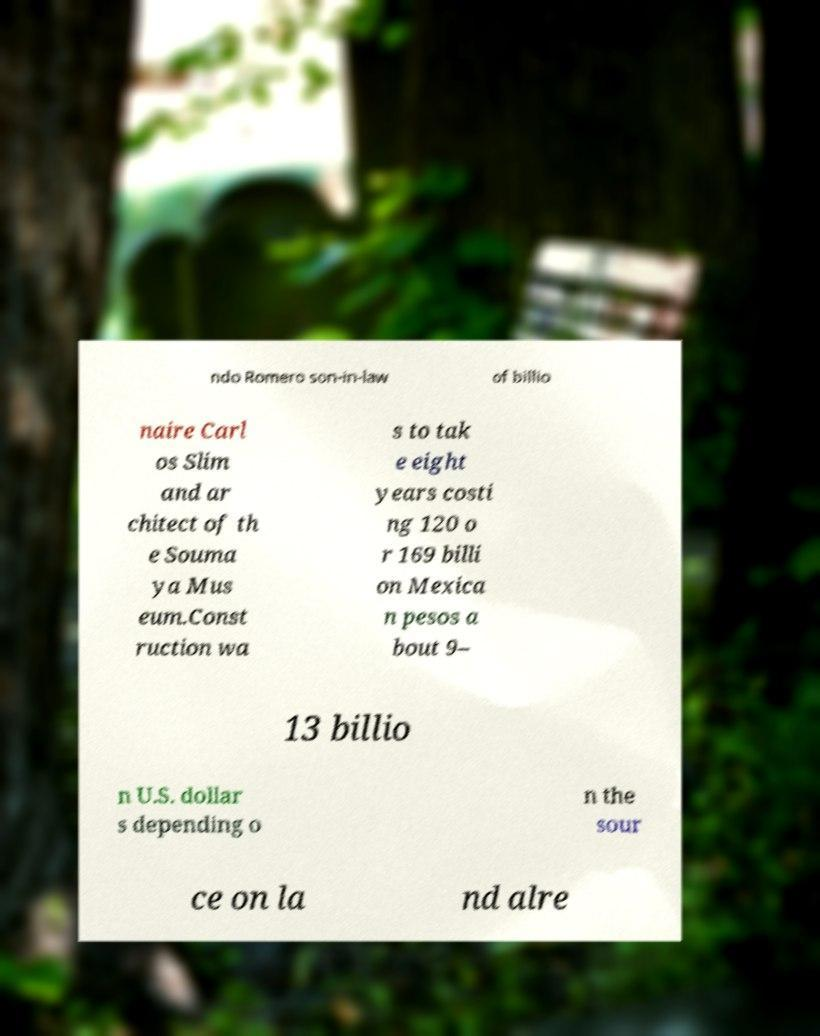Could you extract and type out the text from this image? ndo Romero son-in-law of billio naire Carl os Slim and ar chitect of th e Souma ya Mus eum.Const ruction wa s to tak e eight years costi ng 120 o r 169 billi on Mexica n pesos a bout 9– 13 billio n U.S. dollar s depending o n the sour ce on la nd alre 